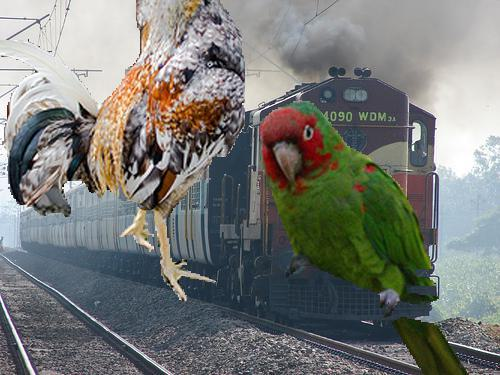What species of birds appear to be photobombing this train? The image humorously incorporates two birds as collage elements; a brightly colored parrot and a chicken are superimposed onto the scene, giving the illusion that they are interacting with the train. This playful approach adds a whimsical touch to the otherwise ordinary depiction of the train, suggesting themes of intrusion or the unexpected intersection of nature and machinery. 